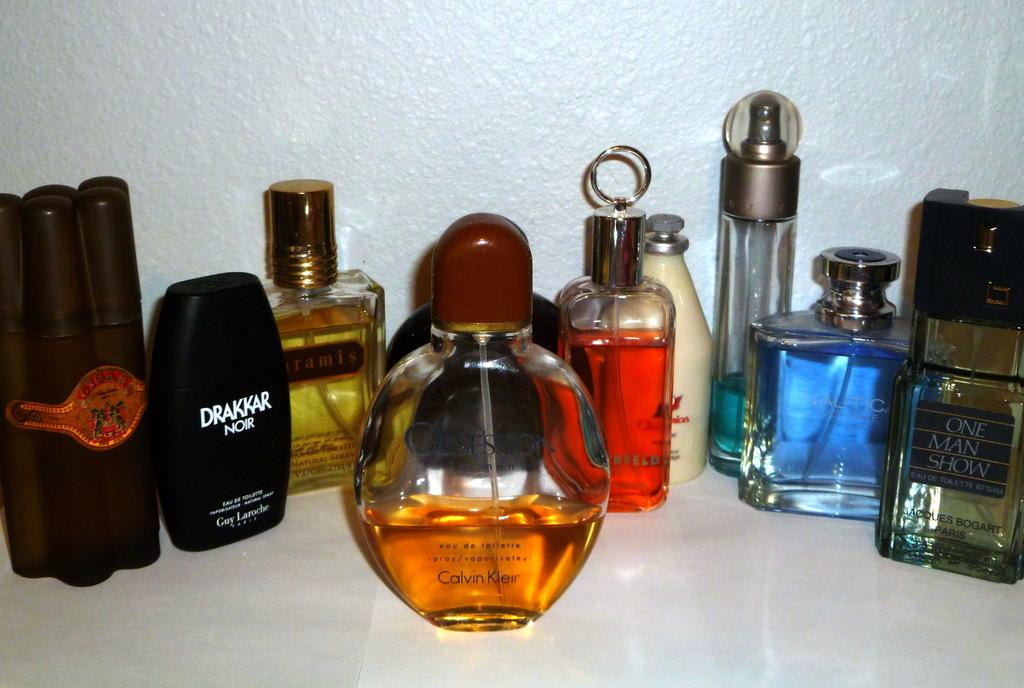<image>
Summarize the visual content of the image. Several colognes from brands such as Drakkar and Calvin Klein sit together on a counter. 